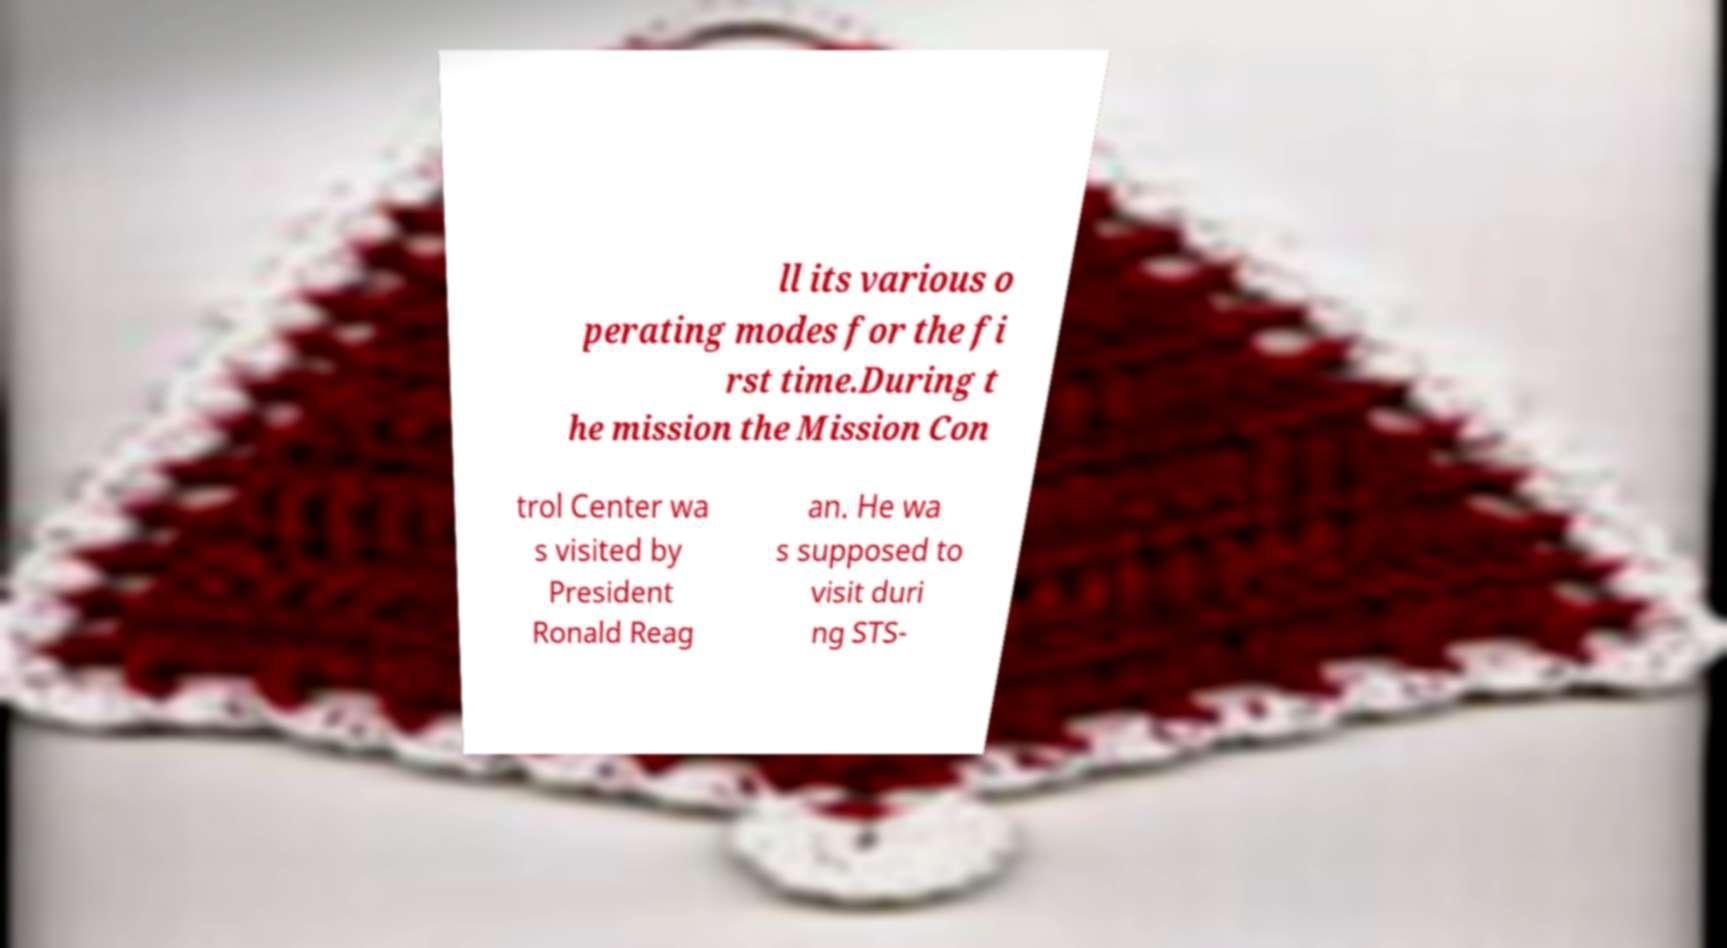Can you read and provide the text displayed in the image?This photo seems to have some interesting text. Can you extract and type it out for me? ll its various o perating modes for the fi rst time.During t he mission the Mission Con trol Center wa s visited by President Ronald Reag an. He wa s supposed to visit duri ng STS- 